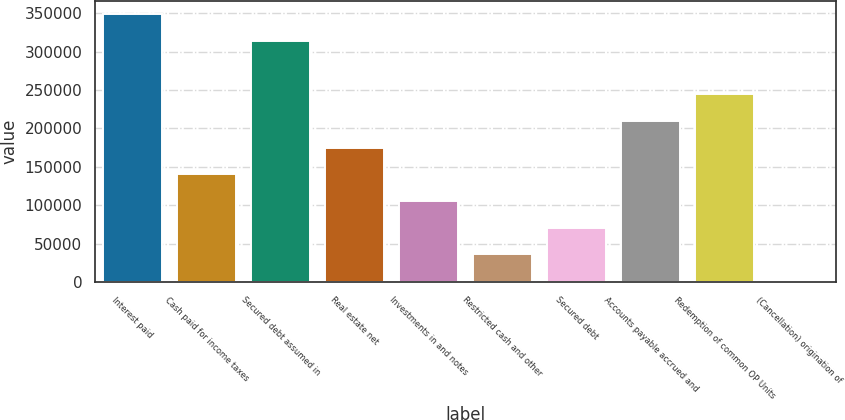Convert chart to OTSL. <chart><loc_0><loc_0><loc_500><loc_500><bar_chart><fcel>Interest paid<fcel>Cash paid for income taxes<fcel>Secured debt assumed in<fcel>Real estate net<fcel>Investments in and notes<fcel>Restricted cash and other<fcel>Secured debt<fcel>Accounts payable accrued and<fcel>Redemption of common OP Units<fcel>(Cancellation) origination of<nl><fcel>348954<fcel>140208<fcel>314265<fcel>174896<fcel>105519<fcel>36140.9<fcel>70829.8<fcel>209585<fcel>244274<fcel>1452<nl></chart> 